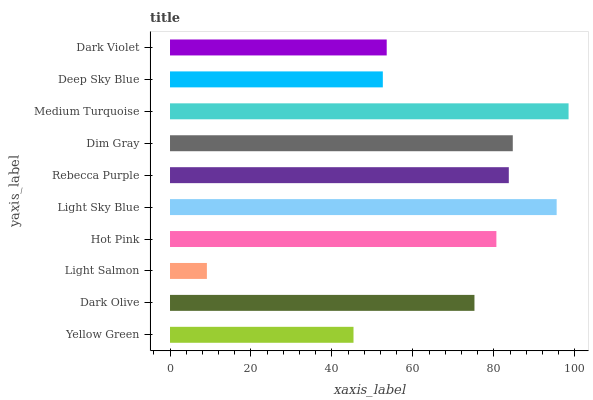Is Light Salmon the minimum?
Answer yes or no. Yes. Is Medium Turquoise the maximum?
Answer yes or no. Yes. Is Dark Olive the minimum?
Answer yes or no. No. Is Dark Olive the maximum?
Answer yes or no. No. Is Dark Olive greater than Yellow Green?
Answer yes or no. Yes. Is Yellow Green less than Dark Olive?
Answer yes or no. Yes. Is Yellow Green greater than Dark Olive?
Answer yes or no. No. Is Dark Olive less than Yellow Green?
Answer yes or no. No. Is Hot Pink the high median?
Answer yes or no. Yes. Is Dark Olive the low median?
Answer yes or no. Yes. Is Deep Sky Blue the high median?
Answer yes or no. No. Is Yellow Green the low median?
Answer yes or no. No. 